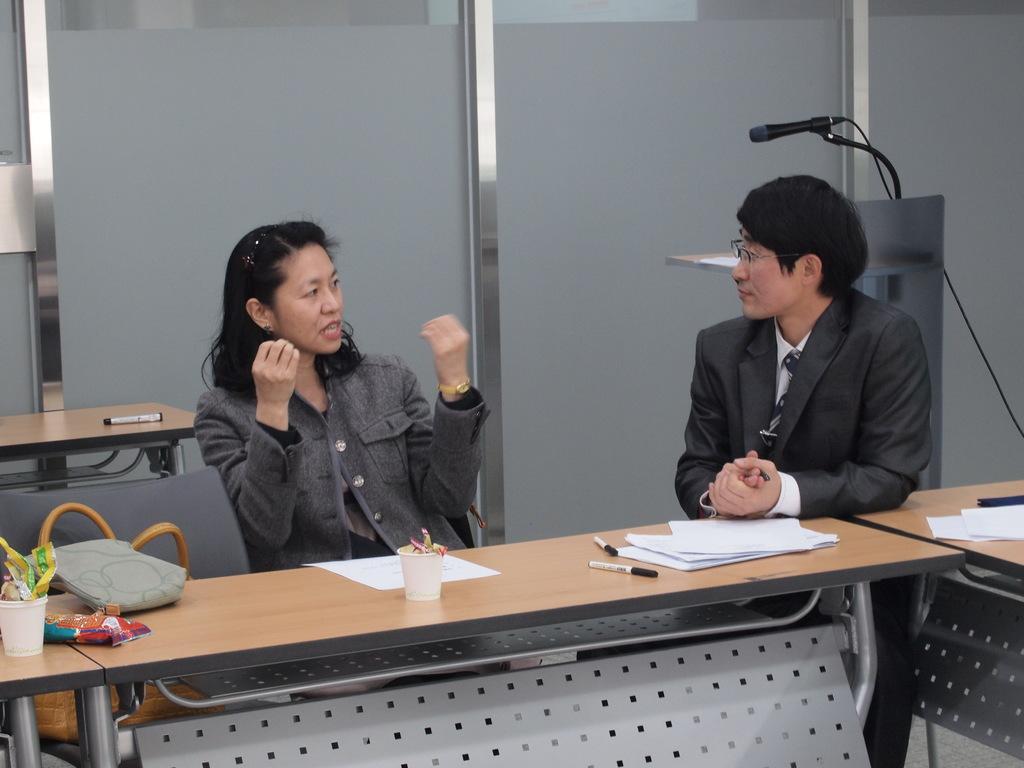Could you give a brief overview of what you see in this image? In this image I can see two people with the dresses. In-front of these people I can see the bag, cups, papers, pens and few more objects on the table. In the background I can see the mic, podium and there is a pen on the table. I can see the window-blinds and I can see the sky through the windows. 